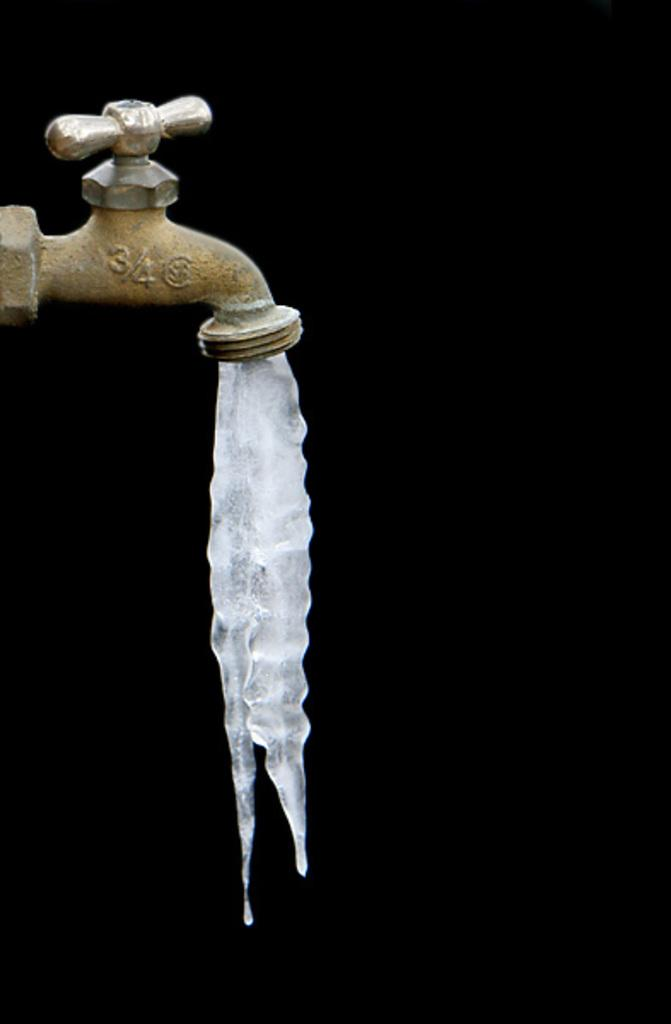What object in the image dispenses liquid or ice? There is a tap in the image that dispenses ice. Can you describe the state of the substance coming from the tap? Ice is coming from the hole of the tap. What type of boot is placed on the chair in the image? There is no boot or chair present in the image; it only features a tap dispensing ice. 